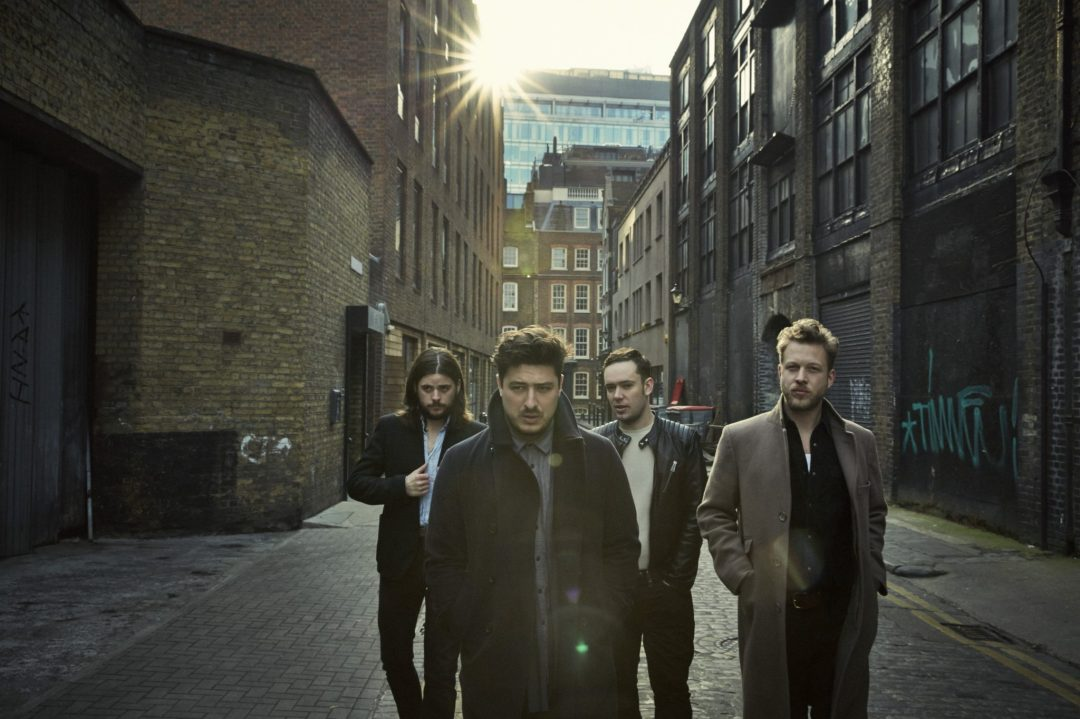Can you describe any notable fashion details observed in what the individuals in the image are wearing? Certainly! The individuals seem to be fashion-conscious, wearing tailored coats that offer warmth while maintaining a sharp look. One individual has a beard and long hair, projecting a bohemian flair. Another wears a scarf, adding both a functional and a stylish touch. The combination suggests an urban, possibly European influence in their fashion choices. 